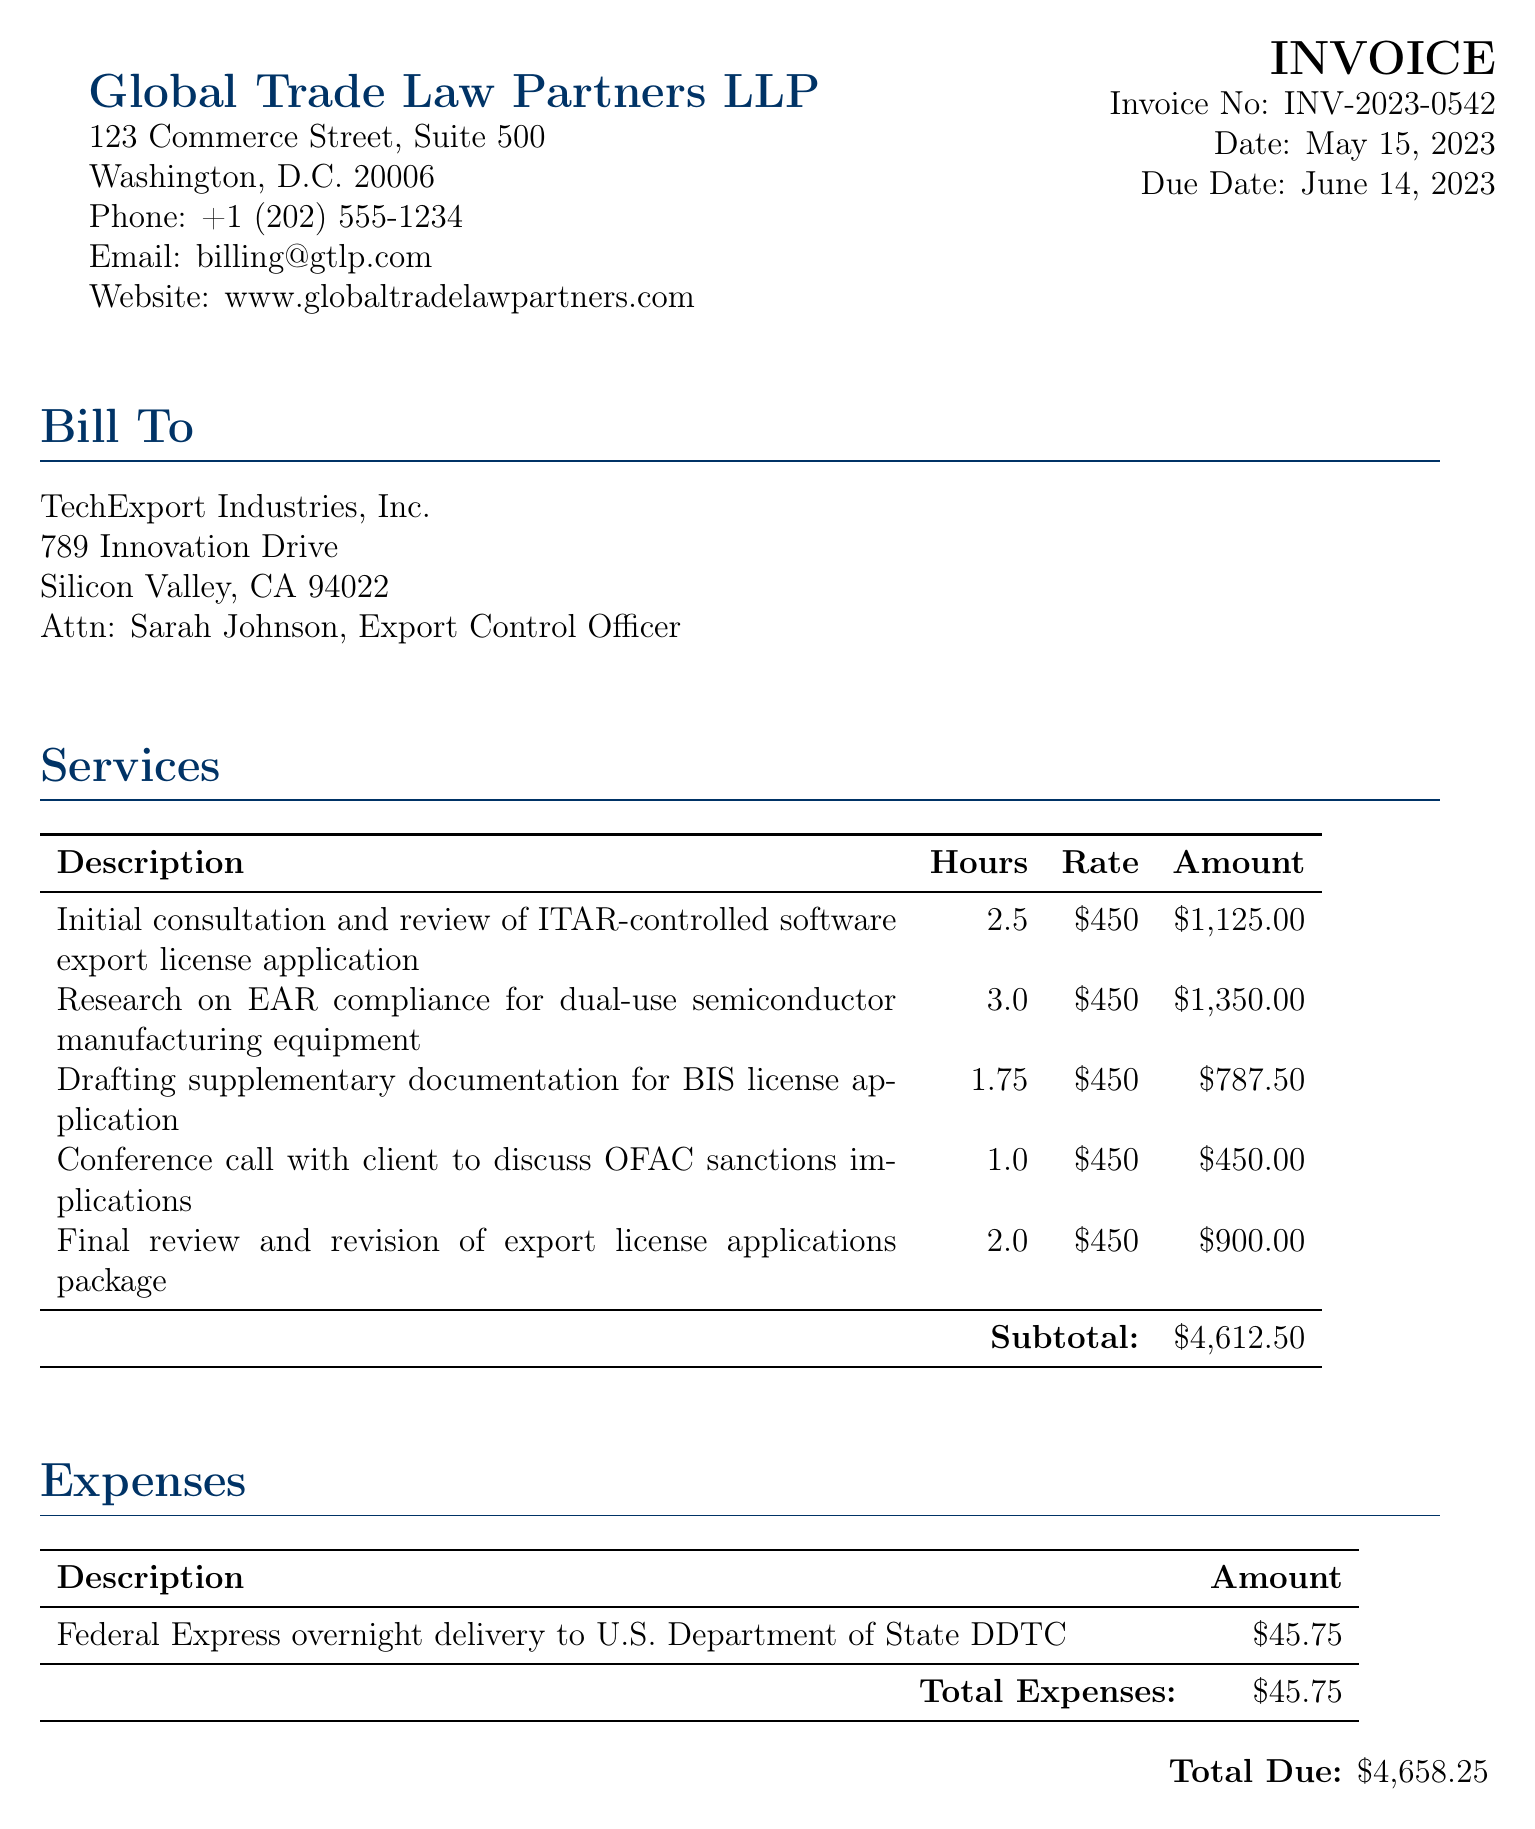What is the invoice number? The invoice number is listed in the document header and is a unique identifier for the bill.
Answer: INV-2023-0542 Who is the bill addressed to? The bill is addressed to TechExport Industries, Inc., and specifies the contact person for billing inquiries.
Answer: TechExport Industries, Inc What is the total amount due? The total amount due is presented at the bottom of the bill, summing all services and expenses.
Answer: $4,658.25 How many hours were spent on research for EAR compliance? The hours for research on EAR compliance are provided in the services section of the bill.
Answer: 3.0 What was the hourly rate charged for legal services? The document states a consistent hourly rate for legal services across all entries in the services section.
Answer: $450 What was the expense for Federal Express delivery? The expense for delivery is listed under the expenses section, showing the cost clearly.
Answer: $45.75 How many services are listed in the bill? The number of service entries can be counted from the services table presented in the document.
Answer: 5 What is the due date for the invoice payment? The due date for the payment is specified in the invoice details.
Answer: June 14, 2023 Who should checks be made payable to? The payment terms section states the entity to whom checks should be payable.
Answer: Global Trade Law Partners LLP 